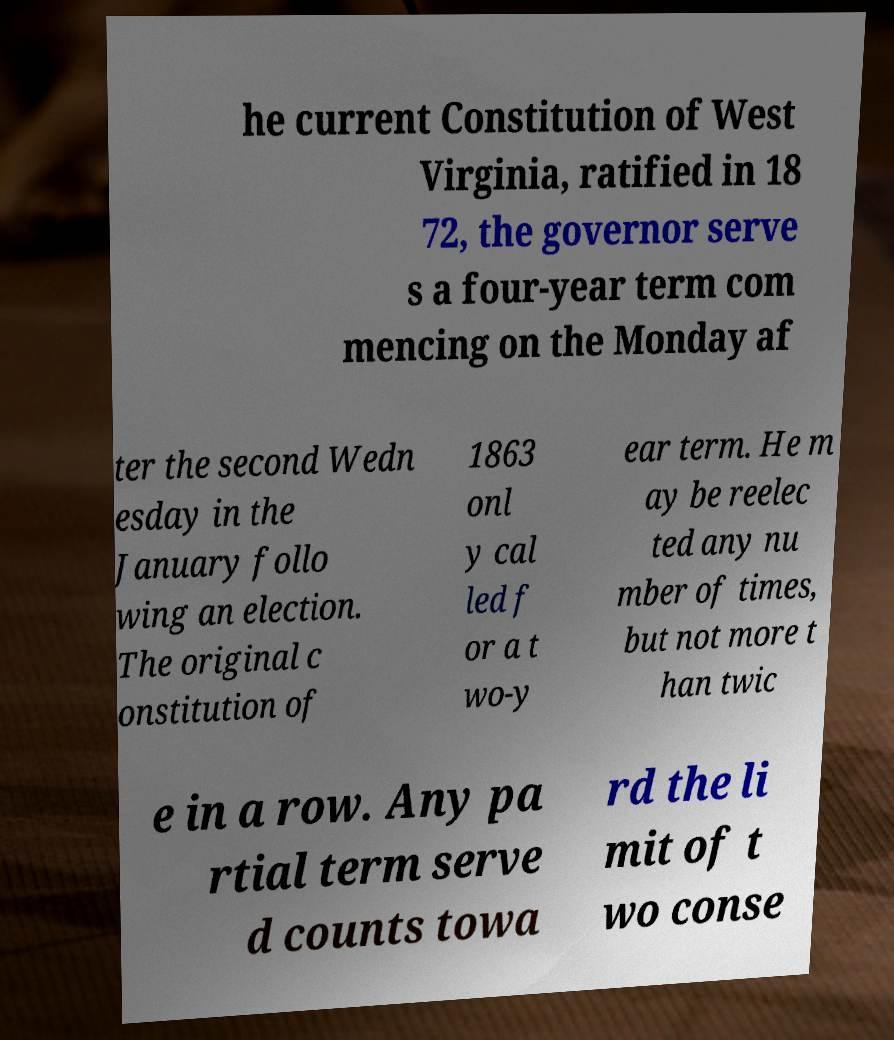I need the written content from this picture converted into text. Can you do that? he current Constitution of West Virginia, ratified in 18 72, the governor serve s a four-year term com mencing on the Monday af ter the second Wedn esday in the January follo wing an election. The original c onstitution of 1863 onl y cal led f or a t wo-y ear term. He m ay be reelec ted any nu mber of times, but not more t han twic e in a row. Any pa rtial term serve d counts towa rd the li mit of t wo conse 